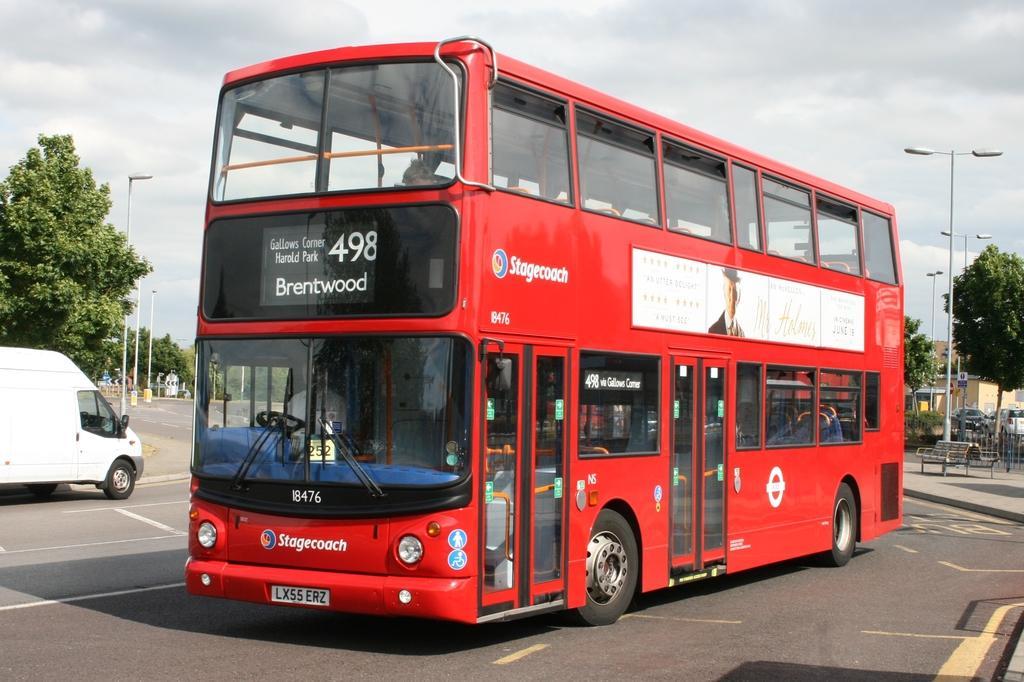Could you give a brief overview of what you see in this image? In this picture we can see a person is sitting in a red Double Decker Bus and the bus is on the road. Behind the bus there is a bench, fence, poles with lights, building, trees, some vehicles on the road and a cloudy sky 